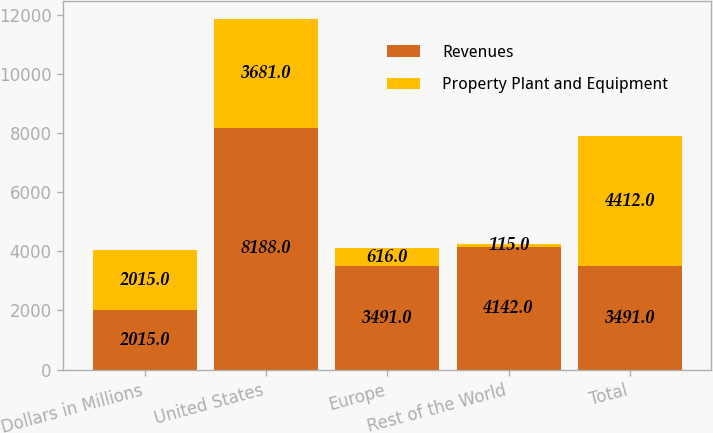Convert chart. <chart><loc_0><loc_0><loc_500><loc_500><stacked_bar_chart><ecel><fcel>Dollars in Millions<fcel>United States<fcel>Europe<fcel>Rest of the World<fcel>Total<nl><fcel>Revenues<fcel>2015<fcel>8188<fcel>3491<fcel>4142<fcel>3491<nl><fcel>Property Plant and Equipment<fcel>2015<fcel>3681<fcel>616<fcel>115<fcel>4412<nl></chart> 